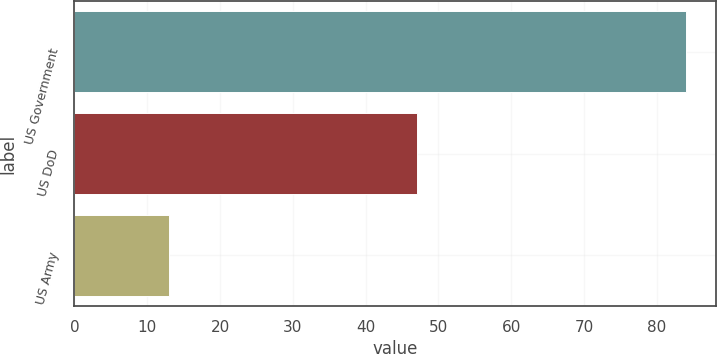Convert chart to OTSL. <chart><loc_0><loc_0><loc_500><loc_500><bar_chart><fcel>US Government<fcel>US DoD<fcel>US Army<nl><fcel>84<fcel>47<fcel>13<nl></chart> 